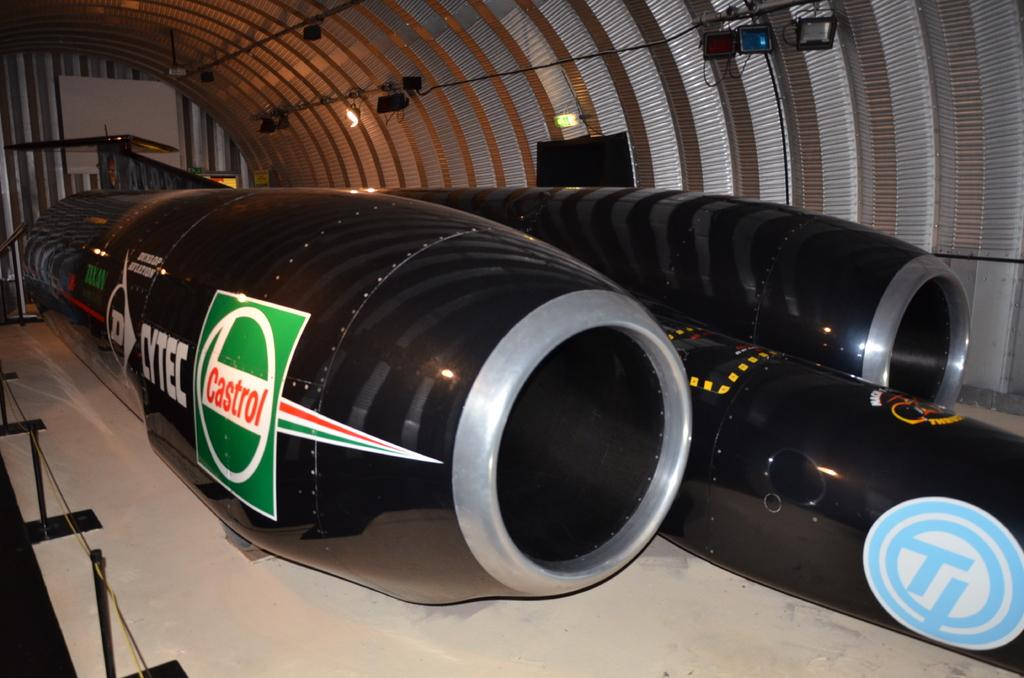<image>
Share a concise interpretation of the image provided. A turbine with a Castrol advertisement on it is painted black. 